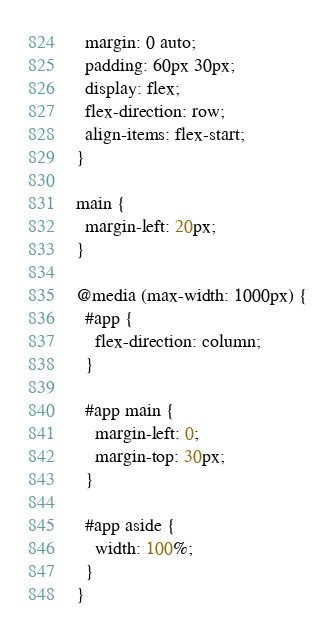Convert code to text. <code><loc_0><loc_0><loc_500><loc_500><_CSS_>  margin: 0 auto;
  padding: 60px 30px;
  display: flex;
  flex-direction: row;
  align-items: flex-start;
}

main {
  margin-left: 20px;
}

@media (max-width: 1000px) {
  #app {
    flex-direction: column;
  }

  #app main {
    margin-left: 0;
    margin-top: 30px;
  }

  #app aside {
    width: 100%;
  }
}</code> 